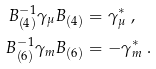Convert formula to latex. <formula><loc_0><loc_0><loc_500><loc_500>B _ { ( 4 ) } ^ { - 1 } \gamma _ { \mu } B _ { ( 4 ) } & = \gamma _ { \mu } ^ { * } \ , \\ B _ { ( 6 ) } ^ { - 1 } \gamma _ { m } B _ { ( 6 ) } & = - \gamma _ { m } ^ { * } \ .</formula> 